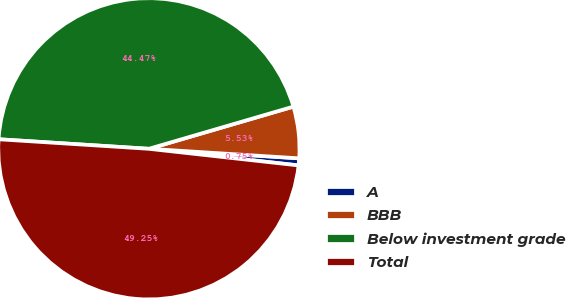Convert chart to OTSL. <chart><loc_0><loc_0><loc_500><loc_500><pie_chart><fcel>A<fcel>BBB<fcel>Below investment grade<fcel>Total<nl><fcel>0.75%<fcel>5.53%<fcel>44.47%<fcel>49.25%<nl></chart> 